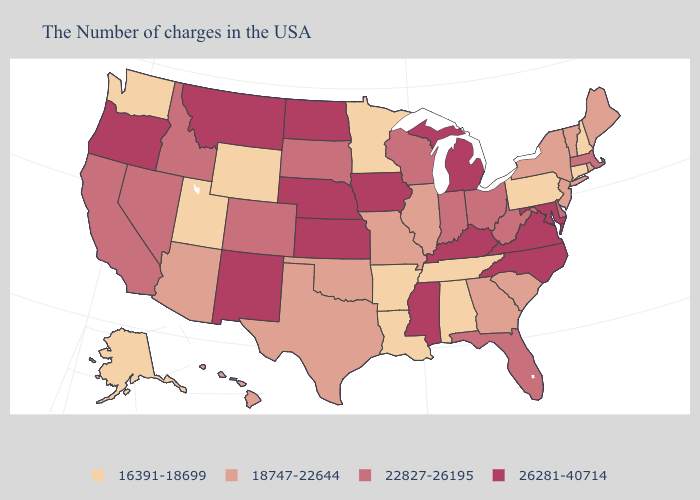What is the value of West Virginia?
Give a very brief answer. 22827-26195. Name the states that have a value in the range 26281-40714?
Give a very brief answer. Maryland, Virginia, North Carolina, Michigan, Kentucky, Mississippi, Iowa, Kansas, Nebraska, North Dakota, New Mexico, Montana, Oregon. Does Iowa have the lowest value in the MidWest?
Answer briefly. No. Name the states that have a value in the range 16391-18699?
Write a very short answer. New Hampshire, Connecticut, Pennsylvania, Alabama, Tennessee, Louisiana, Arkansas, Minnesota, Wyoming, Utah, Washington, Alaska. What is the value of Indiana?
Be succinct. 22827-26195. What is the lowest value in the Northeast?
Be succinct. 16391-18699. What is the value of West Virginia?
Short answer required. 22827-26195. Name the states that have a value in the range 16391-18699?
Short answer required. New Hampshire, Connecticut, Pennsylvania, Alabama, Tennessee, Louisiana, Arkansas, Minnesota, Wyoming, Utah, Washington, Alaska. Name the states that have a value in the range 26281-40714?
Answer briefly. Maryland, Virginia, North Carolina, Michigan, Kentucky, Mississippi, Iowa, Kansas, Nebraska, North Dakota, New Mexico, Montana, Oregon. What is the value of North Carolina?
Keep it brief. 26281-40714. Which states have the highest value in the USA?
Answer briefly. Maryland, Virginia, North Carolina, Michigan, Kentucky, Mississippi, Iowa, Kansas, Nebraska, North Dakota, New Mexico, Montana, Oregon. Among the states that border South Carolina , does Georgia have the lowest value?
Write a very short answer. Yes. Name the states that have a value in the range 22827-26195?
Be succinct. Massachusetts, Delaware, West Virginia, Ohio, Florida, Indiana, Wisconsin, South Dakota, Colorado, Idaho, Nevada, California. What is the value of Florida?
Concise answer only. 22827-26195. 